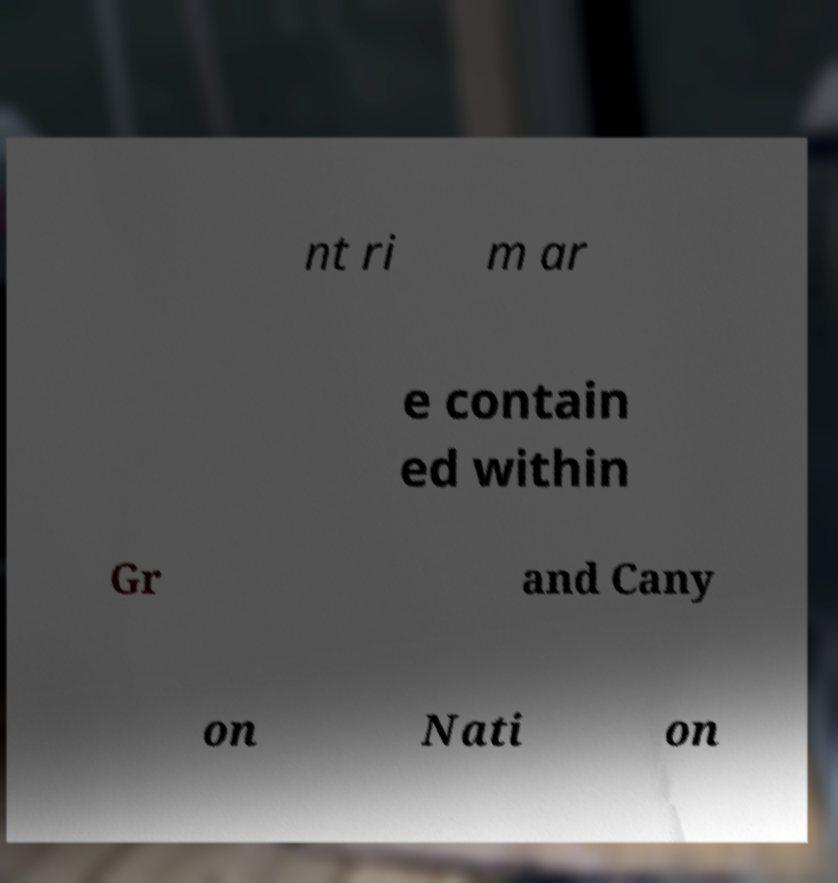Could you assist in decoding the text presented in this image and type it out clearly? nt ri m ar e contain ed within Gr and Cany on Nati on 